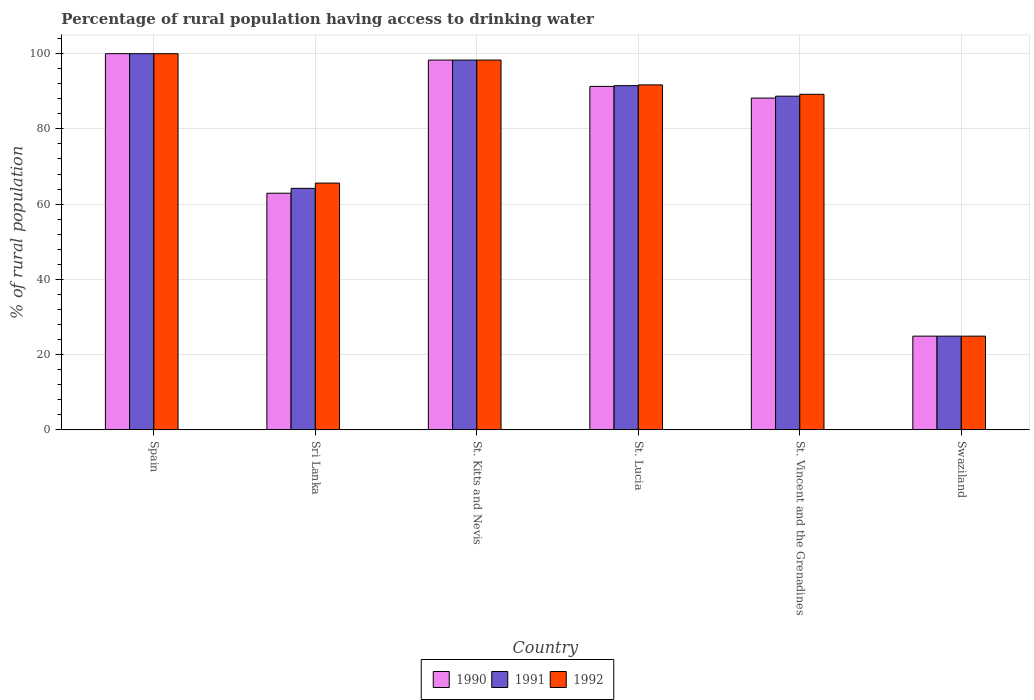How many bars are there on the 2nd tick from the right?
Keep it short and to the point. 3. What is the label of the 3rd group of bars from the left?
Give a very brief answer. St. Kitts and Nevis. In how many cases, is the number of bars for a given country not equal to the number of legend labels?
Ensure brevity in your answer.  0. What is the percentage of rural population having access to drinking water in 1991 in St. Lucia?
Your response must be concise. 91.5. Across all countries, what is the minimum percentage of rural population having access to drinking water in 1992?
Offer a terse response. 24.9. In which country was the percentage of rural population having access to drinking water in 1991 maximum?
Your response must be concise. Spain. In which country was the percentage of rural population having access to drinking water in 1990 minimum?
Give a very brief answer. Swaziland. What is the total percentage of rural population having access to drinking water in 1990 in the graph?
Offer a very short reply. 465.6. What is the difference between the percentage of rural population having access to drinking water in 1991 in Spain and that in St. Kitts and Nevis?
Provide a succinct answer. 1.7. What is the difference between the percentage of rural population having access to drinking water in 1992 in St. Kitts and Nevis and the percentage of rural population having access to drinking water in 1990 in Sri Lanka?
Offer a very short reply. 35.4. What is the average percentage of rural population having access to drinking water in 1992 per country?
Provide a short and direct response. 78.28. In how many countries, is the percentage of rural population having access to drinking water in 1991 greater than 60 %?
Your answer should be very brief. 5. What is the ratio of the percentage of rural population having access to drinking water in 1990 in St. Lucia to that in St. Vincent and the Grenadines?
Offer a very short reply. 1.04. Is the percentage of rural population having access to drinking water in 1990 in St. Vincent and the Grenadines less than that in Swaziland?
Provide a succinct answer. No. Is the difference between the percentage of rural population having access to drinking water in 1991 in St. Kitts and Nevis and St. Vincent and the Grenadines greater than the difference between the percentage of rural population having access to drinking water in 1990 in St. Kitts and Nevis and St. Vincent and the Grenadines?
Provide a succinct answer. No. What is the difference between the highest and the second highest percentage of rural population having access to drinking water in 1991?
Make the answer very short. 6.8. What is the difference between the highest and the lowest percentage of rural population having access to drinking water in 1992?
Your answer should be compact. 75.1. Is the sum of the percentage of rural population having access to drinking water in 1990 in St. Kitts and Nevis and Swaziland greater than the maximum percentage of rural population having access to drinking water in 1992 across all countries?
Provide a short and direct response. Yes. What does the 1st bar from the left in St. Lucia represents?
Give a very brief answer. 1990. What does the 2nd bar from the right in St. Kitts and Nevis represents?
Give a very brief answer. 1991. Is it the case that in every country, the sum of the percentage of rural population having access to drinking water in 1991 and percentage of rural population having access to drinking water in 1992 is greater than the percentage of rural population having access to drinking water in 1990?
Give a very brief answer. Yes. Are all the bars in the graph horizontal?
Provide a succinct answer. No. How many countries are there in the graph?
Make the answer very short. 6. Are the values on the major ticks of Y-axis written in scientific E-notation?
Provide a succinct answer. No. Does the graph contain grids?
Offer a terse response. Yes. Where does the legend appear in the graph?
Keep it short and to the point. Bottom center. How many legend labels are there?
Provide a short and direct response. 3. What is the title of the graph?
Ensure brevity in your answer.  Percentage of rural population having access to drinking water. Does "1990" appear as one of the legend labels in the graph?
Ensure brevity in your answer.  Yes. What is the label or title of the Y-axis?
Offer a terse response. % of rural population. What is the % of rural population of 1990 in Spain?
Make the answer very short. 100. What is the % of rural population in 1990 in Sri Lanka?
Provide a short and direct response. 62.9. What is the % of rural population of 1991 in Sri Lanka?
Ensure brevity in your answer.  64.2. What is the % of rural population of 1992 in Sri Lanka?
Provide a succinct answer. 65.6. What is the % of rural population in 1990 in St. Kitts and Nevis?
Ensure brevity in your answer.  98.3. What is the % of rural population in 1991 in St. Kitts and Nevis?
Give a very brief answer. 98.3. What is the % of rural population of 1992 in St. Kitts and Nevis?
Ensure brevity in your answer.  98.3. What is the % of rural population of 1990 in St. Lucia?
Your response must be concise. 91.3. What is the % of rural population of 1991 in St. Lucia?
Your answer should be very brief. 91.5. What is the % of rural population in 1992 in St. Lucia?
Provide a succinct answer. 91.7. What is the % of rural population in 1990 in St. Vincent and the Grenadines?
Your response must be concise. 88.2. What is the % of rural population of 1991 in St. Vincent and the Grenadines?
Your response must be concise. 88.7. What is the % of rural population of 1992 in St. Vincent and the Grenadines?
Your answer should be compact. 89.2. What is the % of rural population in 1990 in Swaziland?
Your answer should be compact. 24.9. What is the % of rural population of 1991 in Swaziland?
Make the answer very short. 24.9. What is the % of rural population in 1992 in Swaziland?
Provide a short and direct response. 24.9. Across all countries, what is the maximum % of rural population of 1990?
Offer a very short reply. 100. Across all countries, what is the maximum % of rural population of 1991?
Ensure brevity in your answer.  100. Across all countries, what is the maximum % of rural population in 1992?
Your answer should be compact. 100. Across all countries, what is the minimum % of rural population of 1990?
Provide a succinct answer. 24.9. Across all countries, what is the minimum % of rural population in 1991?
Provide a short and direct response. 24.9. Across all countries, what is the minimum % of rural population in 1992?
Keep it short and to the point. 24.9. What is the total % of rural population in 1990 in the graph?
Offer a very short reply. 465.6. What is the total % of rural population of 1991 in the graph?
Offer a terse response. 467.6. What is the total % of rural population of 1992 in the graph?
Provide a short and direct response. 469.7. What is the difference between the % of rural population of 1990 in Spain and that in Sri Lanka?
Make the answer very short. 37.1. What is the difference between the % of rural population of 1991 in Spain and that in Sri Lanka?
Offer a very short reply. 35.8. What is the difference between the % of rural population in 1992 in Spain and that in Sri Lanka?
Give a very brief answer. 34.4. What is the difference between the % of rural population in 1991 in Spain and that in St. Kitts and Nevis?
Your response must be concise. 1.7. What is the difference between the % of rural population in 1992 in Spain and that in St. Kitts and Nevis?
Offer a very short reply. 1.7. What is the difference between the % of rural population in 1991 in Spain and that in St. Lucia?
Make the answer very short. 8.5. What is the difference between the % of rural population of 1990 in Spain and that in St. Vincent and the Grenadines?
Give a very brief answer. 11.8. What is the difference between the % of rural population in 1991 in Spain and that in St. Vincent and the Grenadines?
Your answer should be very brief. 11.3. What is the difference between the % of rural population of 1990 in Spain and that in Swaziland?
Ensure brevity in your answer.  75.1. What is the difference between the % of rural population in 1991 in Spain and that in Swaziland?
Offer a terse response. 75.1. What is the difference between the % of rural population in 1992 in Spain and that in Swaziland?
Offer a very short reply. 75.1. What is the difference between the % of rural population of 1990 in Sri Lanka and that in St. Kitts and Nevis?
Offer a terse response. -35.4. What is the difference between the % of rural population in 1991 in Sri Lanka and that in St. Kitts and Nevis?
Provide a succinct answer. -34.1. What is the difference between the % of rural population in 1992 in Sri Lanka and that in St. Kitts and Nevis?
Offer a very short reply. -32.7. What is the difference between the % of rural population of 1990 in Sri Lanka and that in St. Lucia?
Make the answer very short. -28.4. What is the difference between the % of rural population in 1991 in Sri Lanka and that in St. Lucia?
Keep it short and to the point. -27.3. What is the difference between the % of rural population of 1992 in Sri Lanka and that in St. Lucia?
Give a very brief answer. -26.1. What is the difference between the % of rural population in 1990 in Sri Lanka and that in St. Vincent and the Grenadines?
Ensure brevity in your answer.  -25.3. What is the difference between the % of rural population in 1991 in Sri Lanka and that in St. Vincent and the Grenadines?
Ensure brevity in your answer.  -24.5. What is the difference between the % of rural population in 1992 in Sri Lanka and that in St. Vincent and the Grenadines?
Provide a short and direct response. -23.6. What is the difference between the % of rural population in 1990 in Sri Lanka and that in Swaziland?
Make the answer very short. 38. What is the difference between the % of rural population of 1991 in Sri Lanka and that in Swaziland?
Ensure brevity in your answer.  39.3. What is the difference between the % of rural population of 1992 in Sri Lanka and that in Swaziland?
Offer a terse response. 40.7. What is the difference between the % of rural population of 1992 in St. Kitts and Nevis and that in St. Lucia?
Your response must be concise. 6.6. What is the difference between the % of rural population in 1990 in St. Kitts and Nevis and that in St. Vincent and the Grenadines?
Offer a terse response. 10.1. What is the difference between the % of rural population of 1991 in St. Kitts and Nevis and that in St. Vincent and the Grenadines?
Ensure brevity in your answer.  9.6. What is the difference between the % of rural population of 1992 in St. Kitts and Nevis and that in St. Vincent and the Grenadines?
Provide a short and direct response. 9.1. What is the difference between the % of rural population in 1990 in St. Kitts and Nevis and that in Swaziland?
Ensure brevity in your answer.  73.4. What is the difference between the % of rural population of 1991 in St. Kitts and Nevis and that in Swaziland?
Make the answer very short. 73.4. What is the difference between the % of rural population in 1992 in St. Kitts and Nevis and that in Swaziland?
Your answer should be compact. 73.4. What is the difference between the % of rural population of 1990 in St. Lucia and that in St. Vincent and the Grenadines?
Offer a terse response. 3.1. What is the difference between the % of rural population of 1991 in St. Lucia and that in St. Vincent and the Grenadines?
Offer a terse response. 2.8. What is the difference between the % of rural population in 1992 in St. Lucia and that in St. Vincent and the Grenadines?
Ensure brevity in your answer.  2.5. What is the difference between the % of rural population of 1990 in St. Lucia and that in Swaziland?
Your answer should be compact. 66.4. What is the difference between the % of rural population in 1991 in St. Lucia and that in Swaziland?
Your answer should be very brief. 66.6. What is the difference between the % of rural population of 1992 in St. Lucia and that in Swaziland?
Provide a succinct answer. 66.8. What is the difference between the % of rural population of 1990 in St. Vincent and the Grenadines and that in Swaziland?
Ensure brevity in your answer.  63.3. What is the difference between the % of rural population in 1991 in St. Vincent and the Grenadines and that in Swaziland?
Offer a terse response. 63.8. What is the difference between the % of rural population of 1992 in St. Vincent and the Grenadines and that in Swaziland?
Make the answer very short. 64.3. What is the difference between the % of rural population of 1990 in Spain and the % of rural population of 1991 in Sri Lanka?
Offer a very short reply. 35.8. What is the difference between the % of rural population of 1990 in Spain and the % of rural population of 1992 in Sri Lanka?
Your answer should be very brief. 34.4. What is the difference between the % of rural population of 1991 in Spain and the % of rural population of 1992 in Sri Lanka?
Your answer should be compact. 34.4. What is the difference between the % of rural population in 1990 in Spain and the % of rural population in 1991 in St. Kitts and Nevis?
Your answer should be compact. 1.7. What is the difference between the % of rural population in 1990 in Spain and the % of rural population in 1992 in St. Lucia?
Provide a short and direct response. 8.3. What is the difference between the % of rural population in 1991 in Spain and the % of rural population in 1992 in St. Lucia?
Your response must be concise. 8.3. What is the difference between the % of rural population of 1990 in Spain and the % of rural population of 1991 in Swaziland?
Your answer should be compact. 75.1. What is the difference between the % of rural population in 1990 in Spain and the % of rural population in 1992 in Swaziland?
Your answer should be compact. 75.1. What is the difference between the % of rural population of 1991 in Spain and the % of rural population of 1992 in Swaziland?
Provide a succinct answer. 75.1. What is the difference between the % of rural population of 1990 in Sri Lanka and the % of rural population of 1991 in St. Kitts and Nevis?
Your answer should be very brief. -35.4. What is the difference between the % of rural population in 1990 in Sri Lanka and the % of rural population in 1992 in St. Kitts and Nevis?
Make the answer very short. -35.4. What is the difference between the % of rural population in 1991 in Sri Lanka and the % of rural population in 1992 in St. Kitts and Nevis?
Your answer should be compact. -34.1. What is the difference between the % of rural population of 1990 in Sri Lanka and the % of rural population of 1991 in St. Lucia?
Your answer should be compact. -28.6. What is the difference between the % of rural population of 1990 in Sri Lanka and the % of rural population of 1992 in St. Lucia?
Provide a short and direct response. -28.8. What is the difference between the % of rural population in 1991 in Sri Lanka and the % of rural population in 1992 in St. Lucia?
Ensure brevity in your answer.  -27.5. What is the difference between the % of rural population of 1990 in Sri Lanka and the % of rural population of 1991 in St. Vincent and the Grenadines?
Make the answer very short. -25.8. What is the difference between the % of rural population of 1990 in Sri Lanka and the % of rural population of 1992 in St. Vincent and the Grenadines?
Offer a very short reply. -26.3. What is the difference between the % of rural population of 1990 in Sri Lanka and the % of rural population of 1991 in Swaziland?
Keep it short and to the point. 38. What is the difference between the % of rural population of 1990 in Sri Lanka and the % of rural population of 1992 in Swaziland?
Keep it short and to the point. 38. What is the difference between the % of rural population in 1991 in Sri Lanka and the % of rural population in 1992 in Swaziland?
Provide a succinct answer. 39.3. What is the difference between the % of rural population in 1990 in St. Kitts and Nevis and the % of rural population in 1992 in St. Lucia?
Make the answer very short. 6.6. What is the difference between the % of rural population in 1990 in St. Kitts and Nevis and the % of rural population in 1991 in St. Vincent and the Grenadines?
Your response must be concise. 9.6. What is the difference between the % of rural population in 1990 in St. Kitts and Nevis and the % of rural population in 1991 in Swaziland?
Make the answer very short. 73.4. What is the difference between the % of rural population of 1990 in St. Kitts and Nevis and the % of rural population of 1992 in Swaziland?
Your answer should be very brief. 73.4. What is the difference between the % of rural population of 1991 in St. Kitts and Nevis and the % of rural population of 1992 in Swaziland?
Provide a succinct answer. 73.4. What is the difference between the % of rural population of 1990 in St. Lucia and the % of rural population of 1991 in St. Vincent and the Grenadines?
Keep it short and to the point. 2.6. What is the difference between the % of rural population of 1990 in St. Lucia and the % of rural population of 1992 in St. Vincent and the Grenadines?
Give a very brief answer. 2.1. What is the difference between the % of rural population of 1990 in St. Lucia and the % of rural population of 1991 in Swaziland?
Your response must be concise. 66.4. What is the difference between the % of rural population of 1990 in St. Lucia and the % of rural population of 1992 in Swaziland?
Offer a terse response. 66.4. What is the difference between the % of rural population of 1991 in St. Lucia and the % of rural population of 1992 in Swaziland?
Offer a very short reply. 66.6. What is the difference between the % of rural population in 1990 in St. Vincent and the Grenadines and the % of rural population in 1991 in Swaziland?
Give a very brief answer. 63.3. What is the difference between the % of rural population in 1990 in St. Vincent and the Grenadines and the % of rural population in 1992 in Swaziland?
Offer a very short reply. 63.3. What is the difference between the % of rural population in 1991 in St. Vincent and the Grenadines and the % of rural population in 1992 in Swaziland?
Make the answer very short. 63.8. What is the average % of rural population in 1990 per country?
Your response must be concise. 77.6. What is the average % of rural population in 1991 per country?
Give a very brief answer. 77.93. What is the average % of rural population of 1992 per country?
Your answer should be compact. 78.28. What is the difference between the % of rural population in 1990 and % of rural population in 1991 in Spain?
Offer a very short reply. 0. What is the difference between the % of rural population in 1991 and % of rural population in 1992 in Spain?
Your response must be concise. 0. What is the difference between the % of rural population of 1991 and % of rural population of 1992 in Sri Lanka?
Your response must be concise. -1.4. What is the difference between the % of rural population in 1991 and % of rural population in 1992 in St. Kitts and Nevis?
Your response must be concise. 0. What is the difference between the % of rural population of 1991 and % of rural population of 1992 in St. Lucia?
Offer a terse response. -0.2. What is the difference between the % of rural population of 1990 and % of rural population of 1991 in St. Vincent and the Grenadines?
Make the answer very short. -0.5. What is the difference between the % of rural population of 1990 and % of rural population of 1992 in Swaziland?
Offer a very short reply. 0. What is the ratio of the % of rural population of 1990 in Spain to that in Sri Lanka?
Make the answer very short. 1.59. What is the ratio of the % of rural population in 1991 in Spain to that in Sri Lanka?
Offer a very short reply. 1.56. What is the ratio of the % of rural population of 1992 in Spain to that in Sri Lanka?
Give a very brief answer. 1.52. What is the ratio of the % of rural population of 1990 in Spain to that in St. Kitts and Nevis?
Your response must be concise. 1.02. What is the ratio of the % of rural population of 1991 in Spain to that in St. Kitts and Nevis?
Your answer should be very brief. 1.02. What is the ratio of the % of rural population in 1992 in Spain to that in St. Kitts and Nevis?
Your response must be concise. 1.02. What is the ratio of the % of rural population of 1990 in Spain to that in St. Lucia?
Give a very brief answer. 1.1. What is the ratio of the % of rural population in 1991 in Spain to that in St. Lucia?
Offer a very short reply. 1.09. What is the ratio of the % of rural population in 1992 in Spain to that in St. Lucia?
Offer a terse response. 1.09. What is the ratio of the % of rural population in 1990 in Spain to that in St. Vincent and the Grenadines?
Offer a very short reply. 1.13. What is the ratio of the % of rural population of 1991 in Spain to that in St. Vincent and the Grenadines?
Ensure brevity in your answer.  1.13. What is the ratio of the % of rural population of 1992 in Spain to that in St. Vincent and the Grenadines?
Offer a very short reply. 1.12. What is the ratio of the % of rural population of 1990 in Spain to that in Swaziland?
Your response must be concise. 4.02. What is the ratio of the % of rural population in 1991 in Spain to that in Swaziland?
Ensure brevity in your answer.  4.02. What is the ratio of the % of rural population in 1992 in Spain to that in Swaziland?
Your response must be concise. 4.02. What is the ratio of the % of rural population of 1990 in Sri Lanka to that in St. Kitts and Nevis?
Your answer should be compact. 0.64. What is the ratio of the % of rural population in 1991 in Sri Lanka to that in St. Kitts and Nevis?
Your answer should be compact. 0.65. What is the ratio of the % of rural population of 1992 in Sri Lanka to that in St. Kitts and Nevis?
Offer a terse response. 0.67. What is the ratio of the % of rural population of 1990 in Sri Lanka to that in St. Lucia?
Keep it short and to the point. 0.69. What is the ratio of the % of rural population in 1991 in Sri Lanka to that in St. Lucia?
Give a very brief answer. 0.7. What is the ratio of the % of rural population of 1992 in Sri Lanka to that in St. Lucia?
Ensure brevity in your answer.  0.72. What is the ratio of the % of rural population in 1990 in Sri Lanka to that in St. Vincent and the Grenadines?
Make the answer very short. 0.71. What is the ratio of the % of rural population of 1991 in Sri Lanka to that in St. Vincent and the Grenadines?
Offer a very short reply. 0.72. What is the ratio of the % of rural population of 1992 in Sri Lanka to that in St. Vincent and the Grenadines?
Your answer should be compact. 0.74. What is the ratio of the % of rural population in 1990 in Sri Lanka to that in Swaziland?
Offer a terse response. 2.53. What is the ratio of the % of rural population of 1991 in Sri Lanka to that in Swaziland?
Your answer should be very brief. 2.58. What is the ratio of the % of rural population of 1992 in Sri Lanka to that in Swaziland?
Ensure brevity in your answer.  2.63. What is the ratio of the % of rural population of 1990 in St. Kitts and Nevis to that in St. Lucia?
Make the answer very short. 1.08. What is the ratio of the % of rural population of 1991 in St. Kitts and Nevis to that in St. Lucia?
Ensure brevity in your answer.  1.07. What is the ratio of the % of rural population of 1992 in St. Kitts and Nevis to that in St. Lucia?
Provide a succinct answer. 1.07. What is the ratio of the % of rural population of 1990 in St. Kitts and Nevis to that in St. Vincent and the Grenadines?
Offer a terse response. 1.11. What is the ratio of the % of rural population in 1991 in St. Kitts and Nevis to that in St. Vincent and the Grenadines?
Keep it short and to the point. 1.11. What is the ratio of the % of rural population of 1992 in St. Kitts and Nevis to that in St. Vincent and the Grenadines?
Your answer should be compact. 1.1. What is the ratio of the % of rural population in 1990 in St. Kitts and Nevis to that in Swaziland?
Offer a terse response. 3.95. What is the ratio of the % of rural population in 1991 in St. Kitts and Nevis to that in Swaziland?
Your answer should be very brief. 3.95. What is the ratio of the % of rural population in 1992 in St. Kitts and Nevis to that in Swaziland?
Give a very brief answer. 3.95. What is the ratio of the % of rural population in 1990 in St. Lucia to that in St. Vincent and the Grenadines?
Ensure brevity in your answer.  1.04. What is the ratio of the % of rural population in 1991 in St. Lucia to that in St. Vincent and the Grenadines?
Keep it short and to the point. 1.03. What is the ratio of the % of rural population of 1992 in St. Lucia to that in St. Vincent and the Grenadines?
Your answer should be very brief. 1.03. What is the ratio of the % of rural population in 1990 in St. Lucia to that in Swaziland?
Keep it short and to the point. 3.67. What is the ratio of the % of rural population of 1991 in St. Lucia to that in Swaziland?
Your response must be concise. 3.67. What is the ratio of the % of rural population of 1992 in St. Lucia to that in Swaziland?
Provide a succinct answer. 3.68. What is the ratio of the % of rural population of 1990 in St. Vincent and the Grenadines to that in Swaziland?
Provide a short and direct response. 3.54. What is the ratio of the % of rural population of 1991 in St. Vincent and the Grenadines to that in Swaziland?
Provide a succinct answer. 3.56. What is the ratio of the % of rural population in 1992 in St. Vincent and the Grenadines to that in Swaziland?
Your answer should be very brief. 3.58. What is the difference between the highest and the second highest % of rural population of 1991?
Ensure brevity in your answer.  1.7. What is the difference between the highest and the lowest % of rural population of 1990?
Keep it short and to the point. 75.1. What is the difference between the highest and the lowest % of rural population in 1991?
Make the answer very short. 75.1. What is the difference between the highest and the lowest % of rural population of 1992?
Your response must be concise. 75.1. 